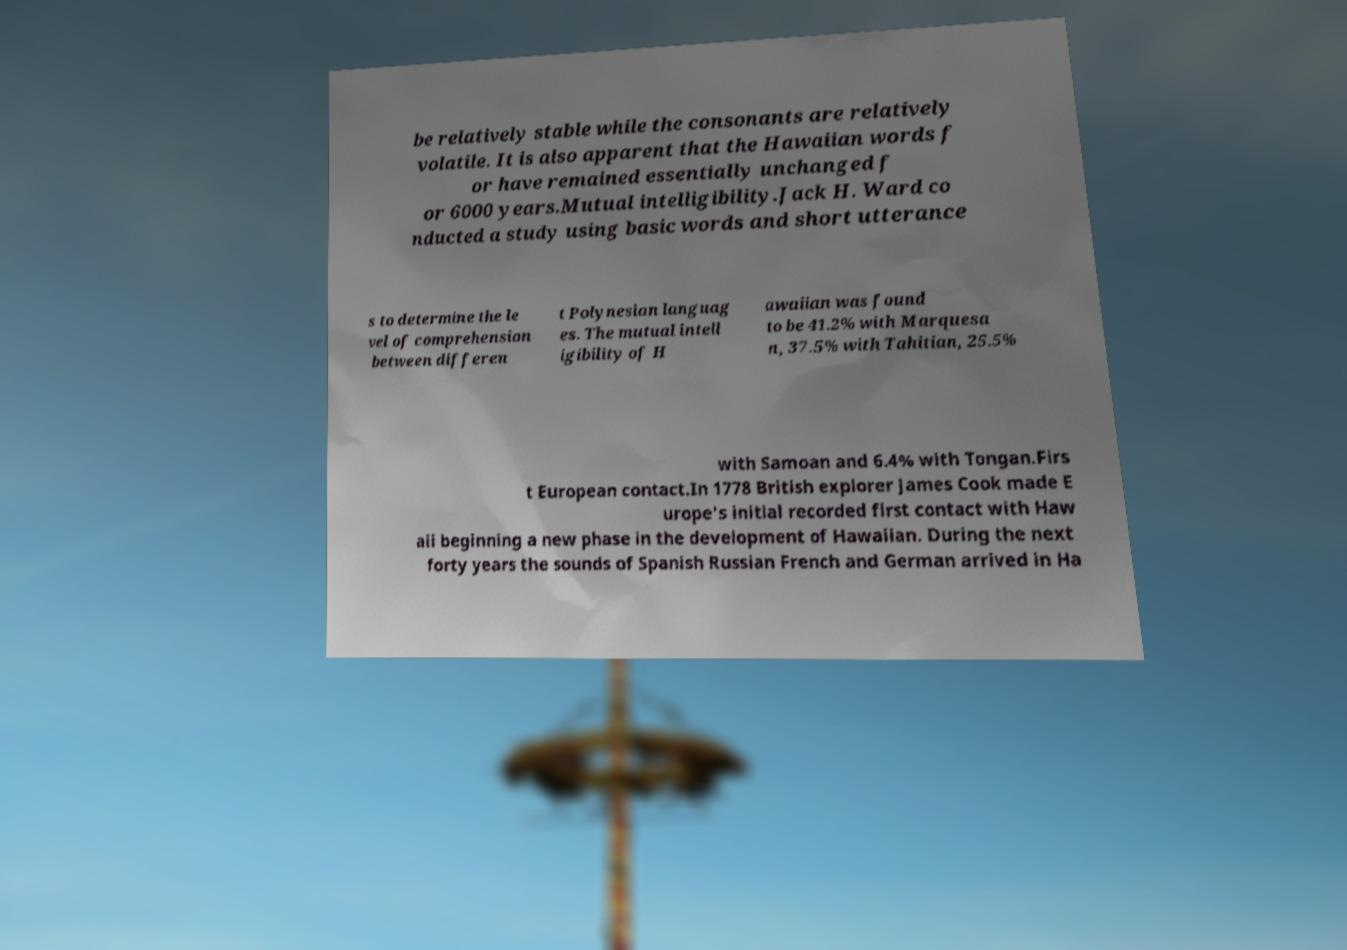For documentation purposes, I need the text within this image transcribed. Could you provide that? be relatively stable while the consonants are relatively volatile. It is also apparent that the Hawaiian words f or have remained essentially unchanged f or 6000 years.Mutual intelligibility.Jack H. Ward co nducted a study using basic words and short utterance s to determine the le vel of comprehension between differen t Polynesian languag es. The mutual intell igibility of H awaiian was found to be 41.2% with Marquesa n, 37.5% with Tahitian, 25.5% with Samoan and 6.4% with Tongan.Firs t European contact.In 1778 British explorer James Cook made E urope's initial recorded first contact with Haw aii beginning a new phase in the development of Hawaiian. During the next forty years the sounds of Spanish Russian French and German arrived in Ha 